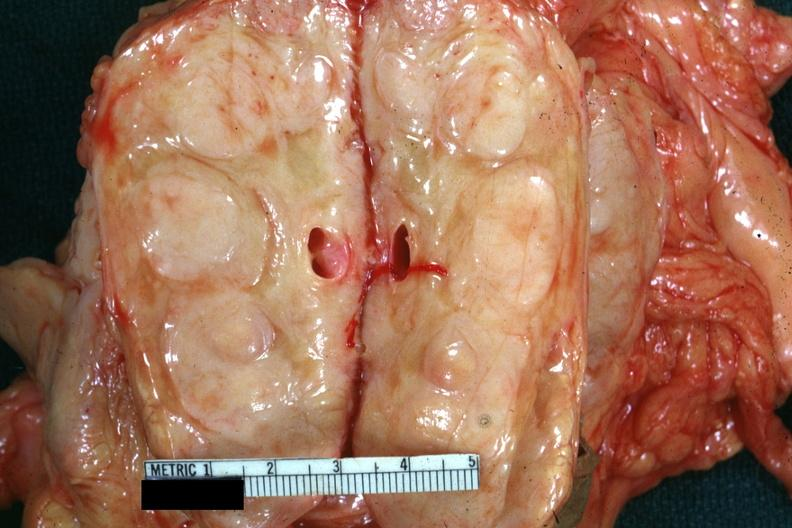what was diagnosed as reticulum cell sarcoma?
Answer the question using a single word or phrase. Example 